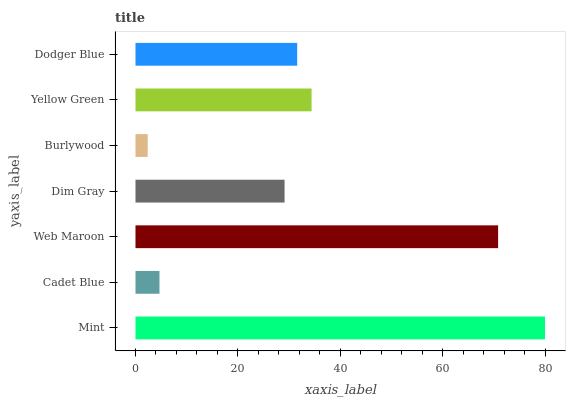Is Burlywood the minimum?
Answer yes or no. Yes. Is Mint the maximum?
Answer yes or no. Yes. Is Cadet Blue the minimum?
Answer yes or no. No. Is Cadet Blue the maximum?
Answer yes or no. No. Is Mint greater than Cadet Blue?
Answer yes or no. Yes. Is Cadet Blue less than Mint?
Answer yes or no. Yes. Is Cadet Blue greater than Mint?
Answer yes or no. No. Is Mint less than Cadet Blue?
Answer yes or no. No. Is Dodger Blue the high median?
Answer yes or no. Yes. Is Dodger Blue the low median?
Answer yes or no. Yes. Is Mint the high median?
Answer yes or no. No. Is Mint the low median?
Answer yes or no. No. 